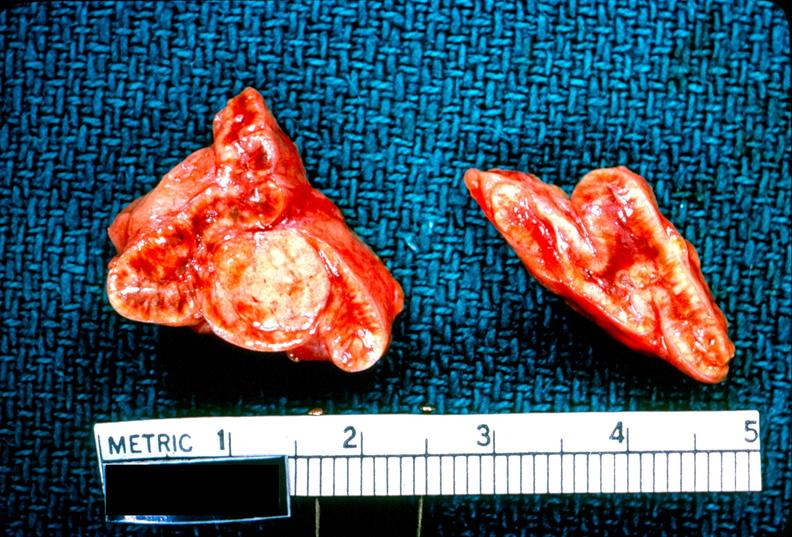what does this image show?
Answer the question using a single word or phrase. Adrenal 